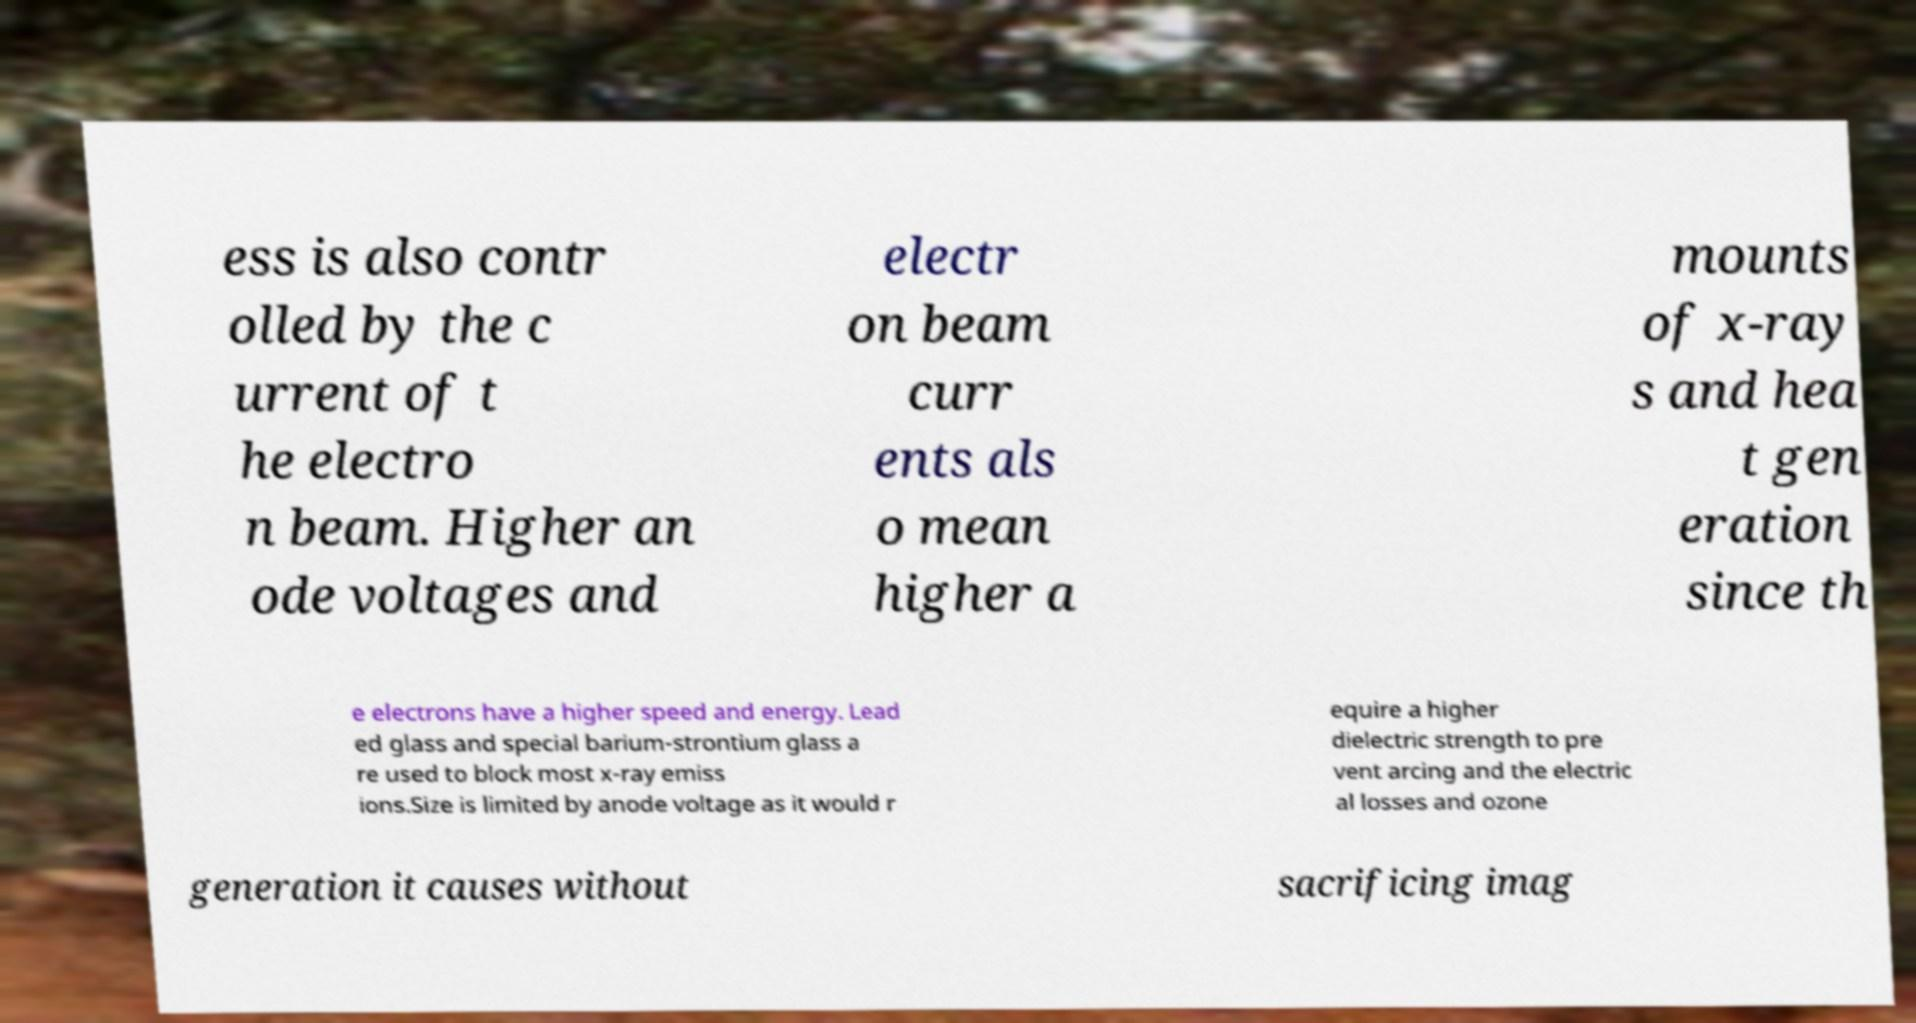Could you extract and type out the text from this image? ess is also contr olled by the c urrent of t he electro n beam. Higher an ode voltages and electr on beam curr ents als o mean higher a mounts of x-ray s and hea t gen eration since th e electrons have a higher speed and energy. Lead ed glass and special barium-strontium glass a re used to block most x-ray emiss ions.Size is limited by anode voltage as it would r equire a higher dielectric strength to pre vent arcing and the electric al losses and ozone generation it causes without sacrificing imag 